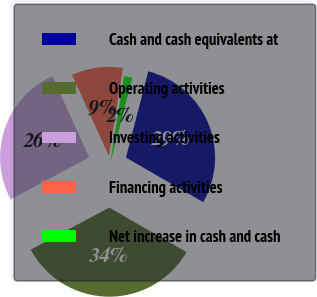Convert chart. <chart><loc_0><loc_0><loc_500><loc_500><pie_chart><fcel>Cash and cash equivalents at<fcel>Operating activities<fcel>Investing activities<fcel>Financing activities<fcel>Net increase in cash and cash<nl><fcel>29.29%<fcel>33.83%<fcel>26.06%<fcel>9.31%<fcel>1.5%<nl></chart> 